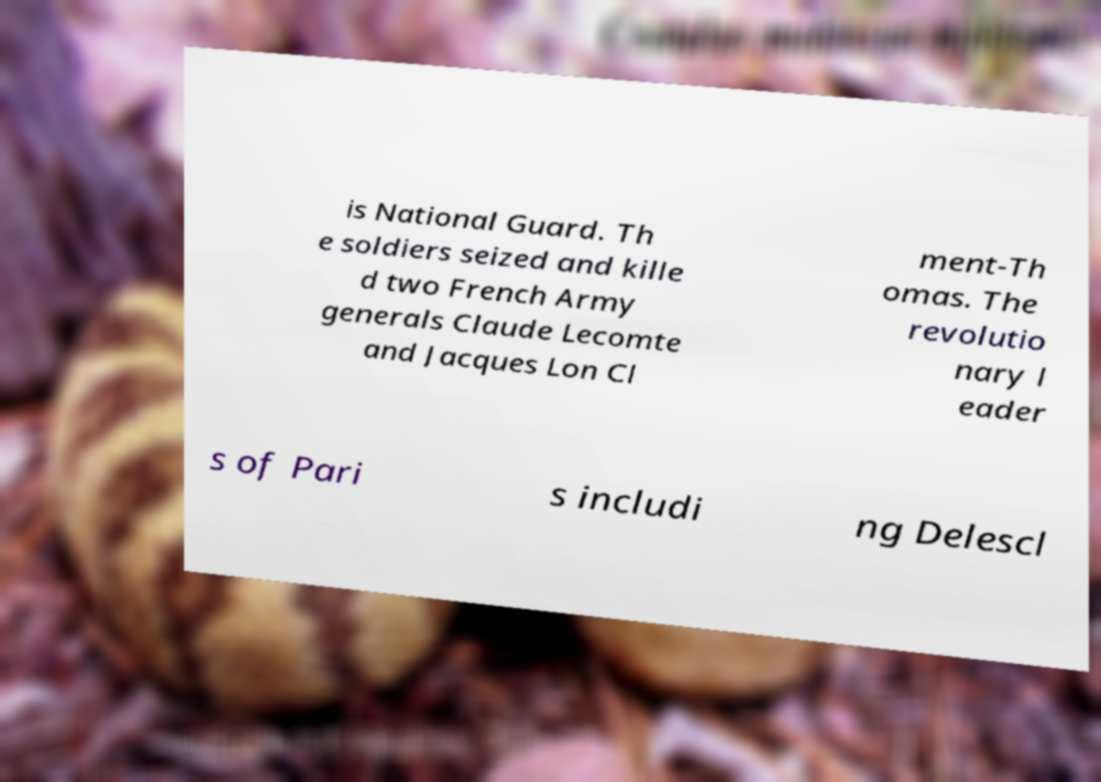Please identify and transcribe the text found in this image. is National Guard. Th e soldiers seized and kille d two French Army generals Claude Lecomte and Jacques Lon Cl ment-Th omas. The revolutio nary l eader s of Pari s includi ng Delescl 